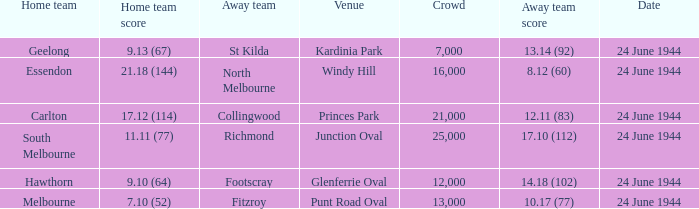When the Crowd was larger than 25,000. what was the Home Team score? None. Write the full table. {'header': ['Home team', 'Home team score', 'Away team', 'Venue', 'Crowd', 'Away team score', 'Date'], 'rows': [['Geelong', '9.13 (67)', 'St Kilda', 'Kardinia Park', '7,000', '13.14 (92)', '24 June 1944'], ['Essendon', '21.18 (144)', 'North Melbourne', 'Windy Hill', '16,000', '8.12 (60)', '24 June 1944'], ['Carlton', '17.12 (114)', 'Collingwood', 'Princes Park', '21,000', '12.11 (83)', '24 June 1944'], ['South Melbourne', '11.11 (77)', 'Richmond', 'Junction Oval', '25,000', '17.10 (112)', '24 June 1944'], ['Hawthorn', '9.10 (64)', 'Footscray', 'Glenferrie Oval', '12,000', '14.18 (102)', '24 June 1944'], ['Melbourne', '7.10 (52)', 'Fitzroy', 'Punt Road Oval', '13,000', '10.17 (77)', '24 June 1944']]} 